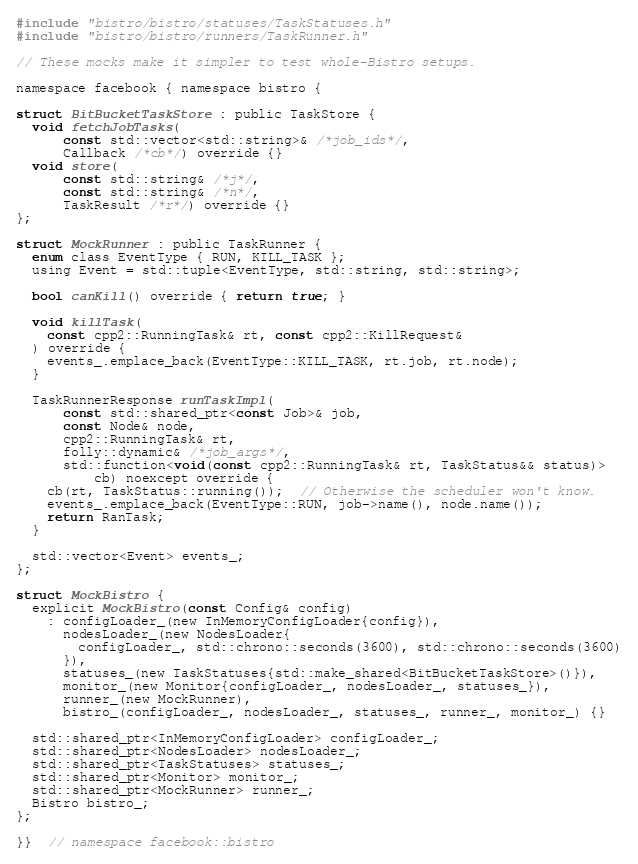Convert code to text. <code><loc_0><loc_0><loc_500><loc_500><_C_>#include "bistro/bistro/statuses/TaskStatuses.h"
#include "bistro/bistro/runners/TaskRunner.h"

// These mocks make it simpler to test whole-Bistro setups.

namespace facebook { namespace bistro {

struct BitBucketTaskStore : public TaskStore {
  void fetchJobTasks(
      const std::vector<std::string>& /*job_ids*/,
      Callback /*cb*/) override {}
  void store(
      const std::string& /*j*/,
      const std::string& /*n*/,
      TaskResult /*r*/) override {}
};

struct MockRunner : public TaskRunner {
  enum class EventType { RUN, KILL_TASK };
  using Event = std::tuple<EventType, std::string, std::string>;

  bool canKill() override { return true; }

  void killTask(
    const cpp2::RunningTask& rt, const cpp2::KillRequest&
  ) override {
    events_.emplace_back(EventType::KILL_TASK, rt.job, rt.node);
  }

  TaskRunnerResponse runTaskImpl(
      const std::shared_ptr<const Job>& job,
      const Node& node,
      cpp2::RunningTask& rt,
      folly::dynamic& /*job_args*/,
      std::function<void(const cpp2::RunningTask& rt, TaskStatus&& status)>
          cb) noexcept override {
    cb(rt, TaskStatus::running());  // Otherwise the scheduler won't know.
    events_.emplace_back(EventType::RUN, job->name(), node.name());
    return RanTask;
  }

  std::vector<Event> events_;
};

struct MockBistro {
  explicit MockBistro(const Config& config)
    : configLoader_(new InMemoryConfigLoader{config}),
      nodesLoader_(new NodesLoader{
        configLoader_, std::chrono::seconds(3600), std::chrono::seconds(3600)
      }),
      statuses_(new TaskStatuses{std::make_shared<BitBucketTaskStore>()}),
      monitor_(new Monitor{configLoader_, nodesLoader_, statuses_}),
      runner_(new MockRunner),
      bistro_(configLoader_, nodesLoader_, statuses_, runner_, monitor_) {}

  std::shared_ptr<InMemoryConfigLoader> configLoader_;
  std::shared_ptr<NodesLoader> nodesLoader_;
  std::shared_ptr<TaskStatuses> statuses_;
  std::shared_ptr<Monitor> monitor_;
  std::shared_ptr<MockRunner> runner_;
  Bistro bistro_;
};

}}  // namespace facebook::bistro
</code> 